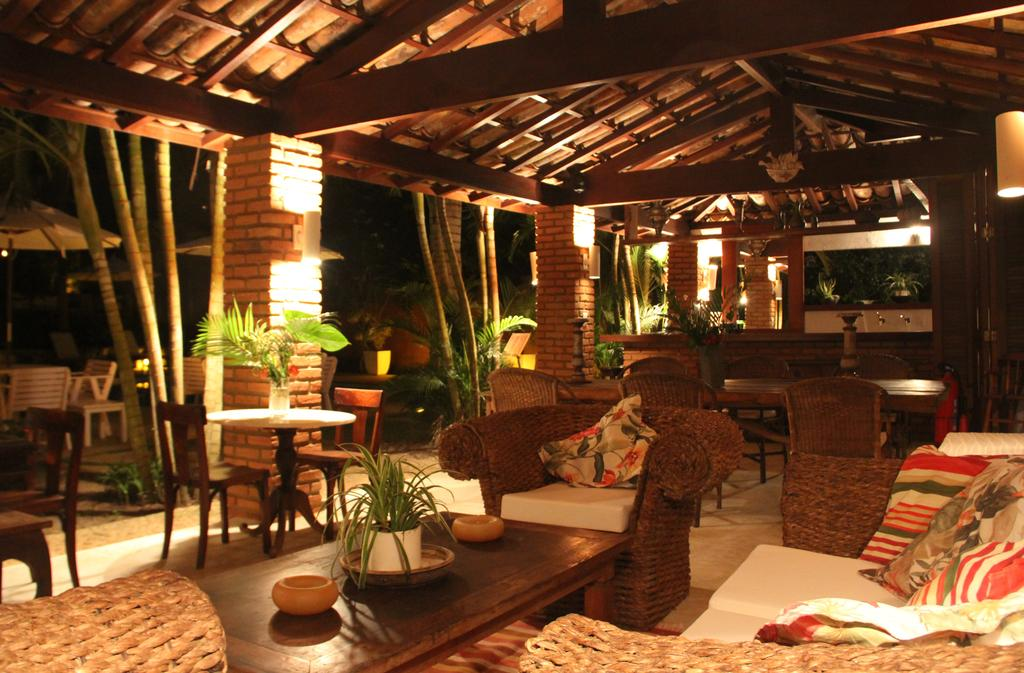What type of furniture is present in the image? There are chairs and tables in the image. What is placed on the furniture for added comfort? There are cushions on the couches. What type of decorative elements can be seen in the image? There are plants in the image. What type of natural elements are visible in the background? There are trees in the image. Can you tell me how many eyes are visible on the plants in the image? Plants do not have eyes, so there are no eyes visible on the plants in the image. 